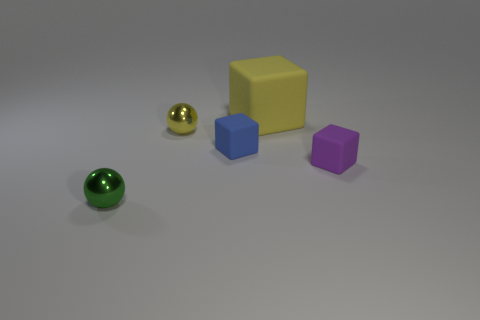Is there any other thing that has the same material as the small blue object?
Offer a very short reply. Yes. Do the blue matte object and the metal thing behind the tiny green metal thing have the same size?
Offer a terse response. Yes. How many other things are the same color as the big rubber block?
Provide a succinct answer. 1. Are there any small yellow shiny spheres to the left of the big yellow object?
Provide a succinct answer. Yes. What number of things are either tiny metal balls or tiny shiny spheres that are in front of the tiny blue rubber block?
Make the answer very short. 2. Is there a tiny green shiny ball right of the cube that is right of the large yellow thing?
Give a very brief answer. No. What is the shape of the tiny thing in front of the tiny purple matte thing behind the tiny sphere that is on the left side of the yellow ball?
Give a very brief answer. Sphere. What color is the small thing that is in front of the small yellow ball and left of the tiny blue block?
Make the answer very short. Green. What shape is the small matte thing that is left of the tiny purple cube?
Provide a succinct answer. Cube. What is the shape of the large yellow thing that is the same material as the tiny purple thing?
Provide a short and direct response. Cube. 